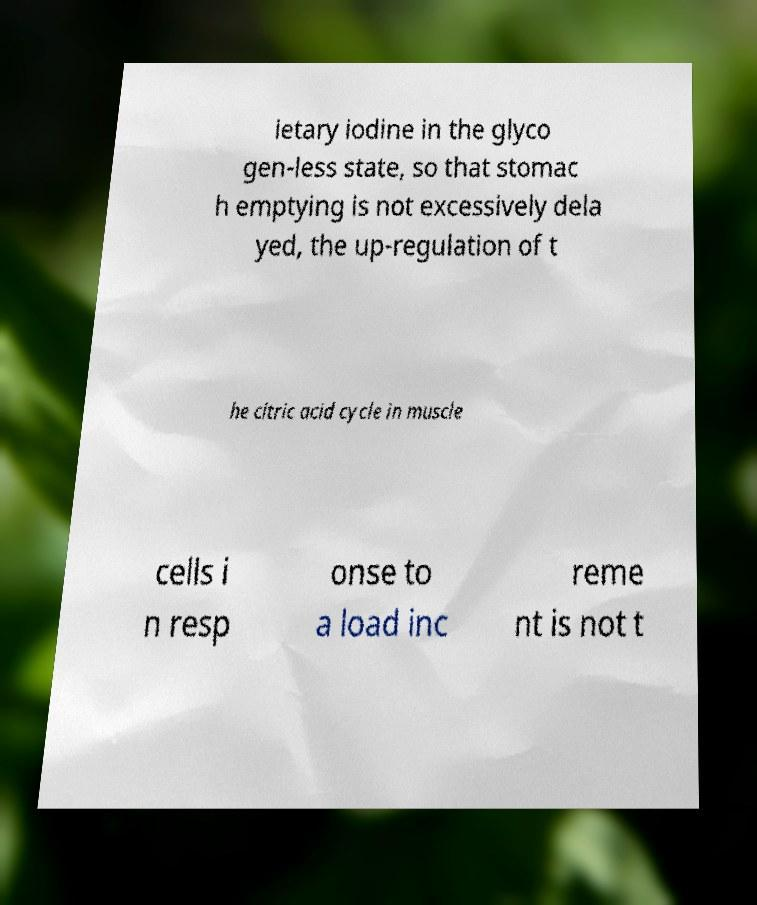What messages or text are displayed in this image? I need them in a readable, typed format. ietary iodine in the glyco gen-less state, so that stomac h emptying is not excessively dela yed, the up-regulation of t he citric acid cycle in muscle cells i n resp onse to a load inc reme nt is not t 